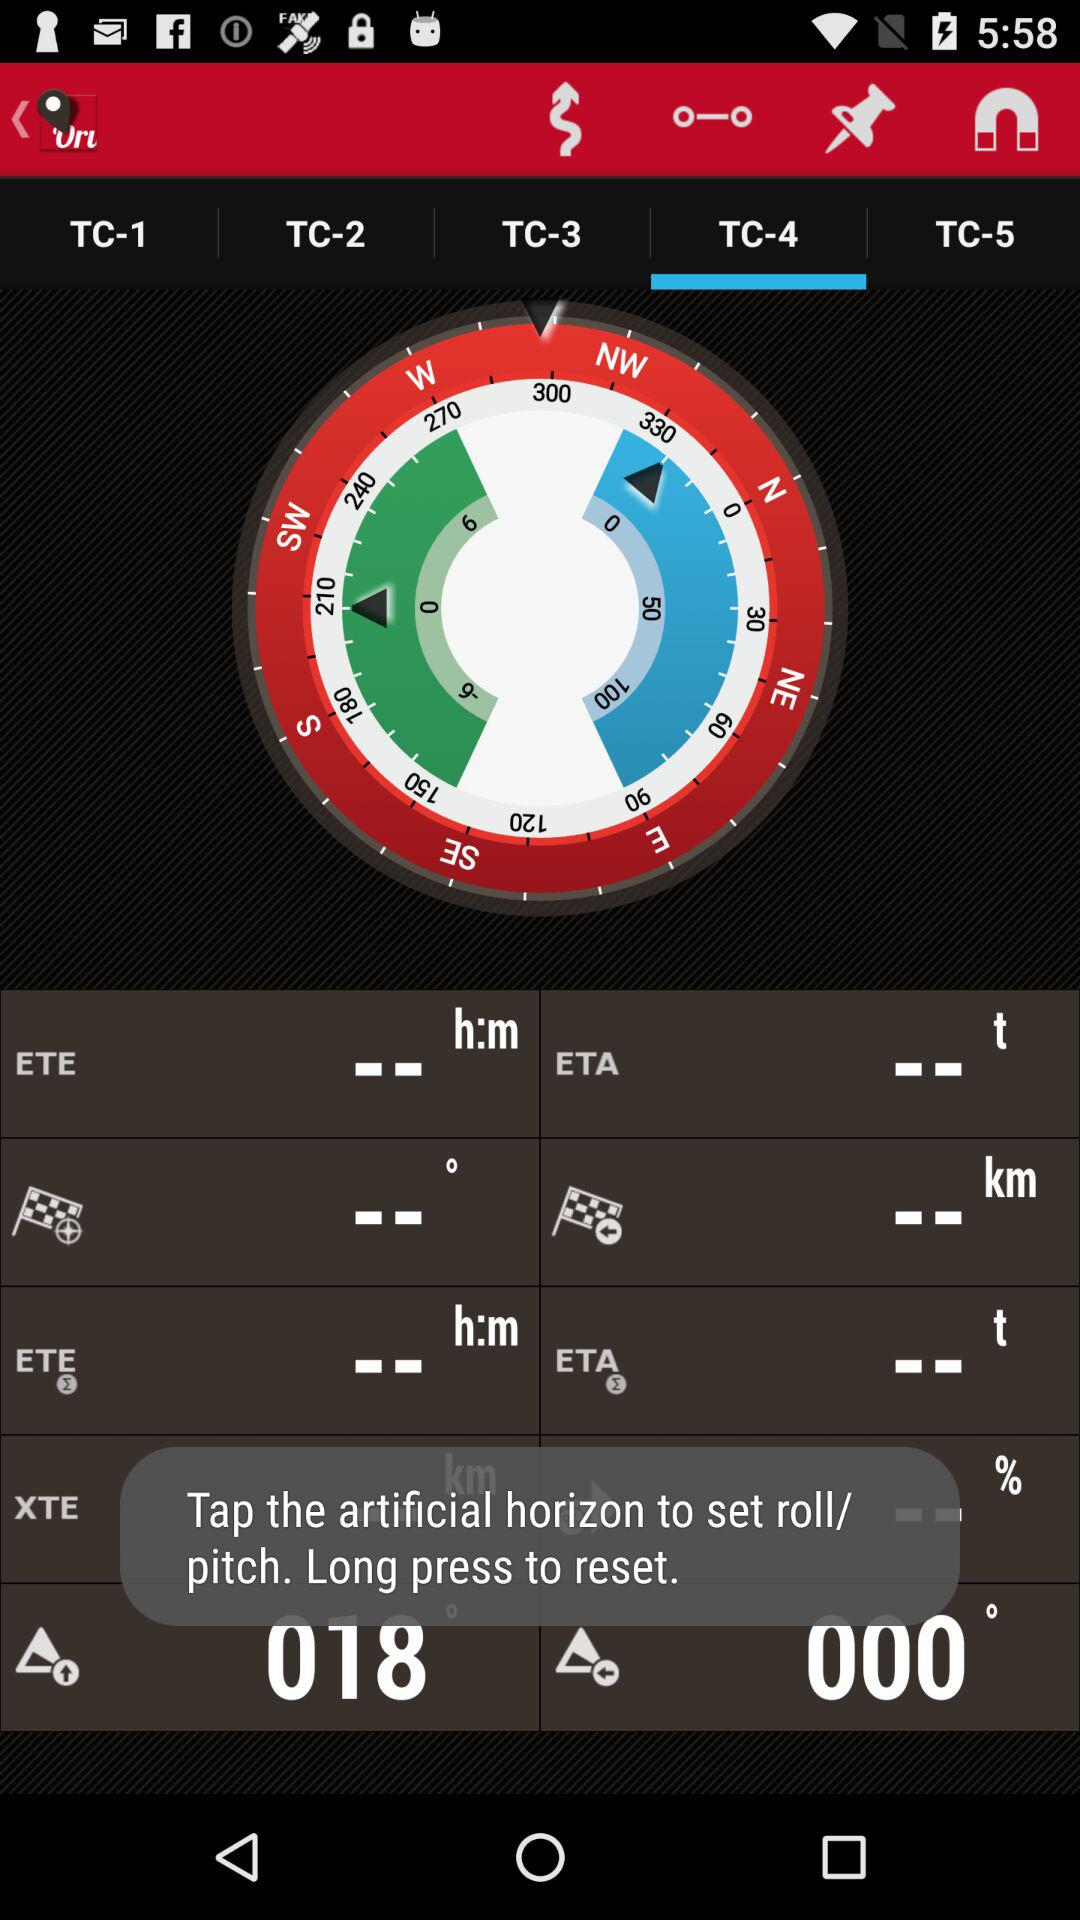Which tab is open? The open tab is "TC-4". 